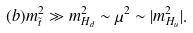<formula> <loc_0><loc_0><loc_500><loc_500>( b ) m _ { \tilde { t } } ^ { 2 } \gg m _ { H _ { d } } ^ { 2 } \sim \mu ^ { 2 } \sim | m _ { H _ { u } } ^ { 2 } | .</formula> 